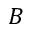Convert formula to latex. <formula><loc_0><loc_0><loc_500><loc_500>B</formula> 